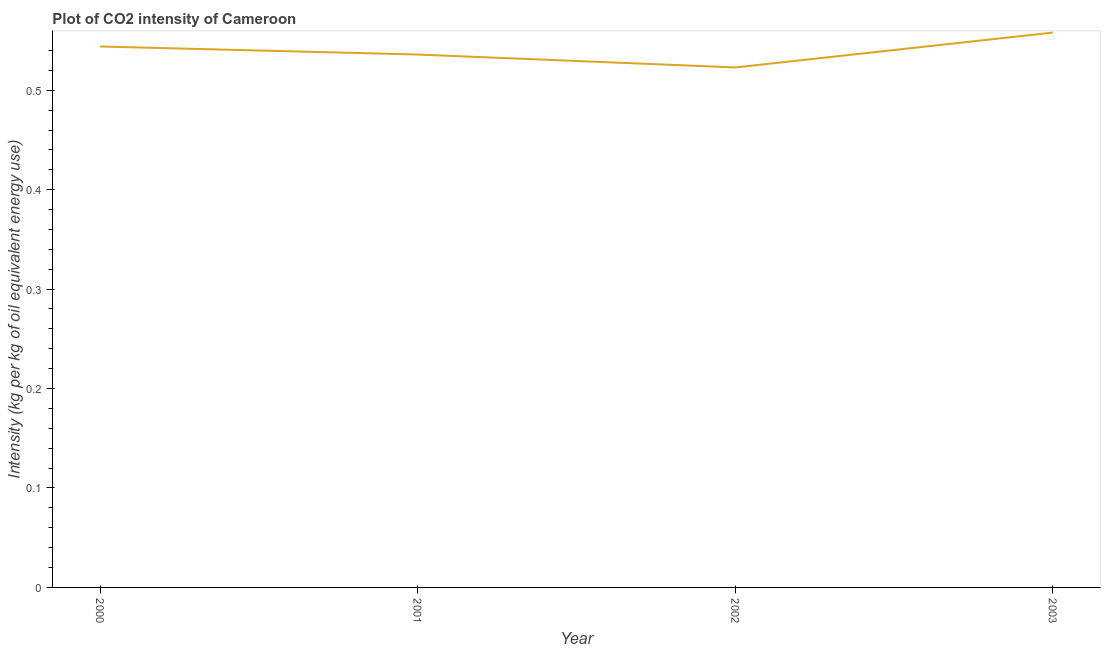What is the co2 intensity in 2002?
Keep it short and to the point. 0.52. Across all years, what is the maximum co2 intensity?
Provide a succinct answer. 0.56. Across all years, what is the minimum co2 intensity?
Your answer should be very brief. 0.52. What is the sum of the co2 intensity?
Offer a very short reply. 2.16. What is the difference between the co2 intensity in 2000 and 2002?
Make the answer very short. 0.02. What is the average co2 intensity per year?
Provide a succinct answer. 0.54. What is the median co2 intensity?
Offer a very short reply. 0.54. In how many years, is the co2 intensity greater than 0.32000000000000006 kg?
Make the answer very short. 4. What is the ratio of the co2 intensity in 2001 to that in 2002?
Your answer should be very brief. 1.02. What is the difference between the highest and the second highest co2 intensity?
Ensure brevity in your answer.  0.01. Is the sum of the co2 intensity in 2001 and 2003 greater than the maximum co2 intensity across all years?
Offer a terse response. Yes. What is the difference between the highest and the lowest co2 intensity?
Your response must be concise. 0.04. In how many years, is the co2 intensity greater than the average co2 intensity taken over all years?
Keep it short and to the point. 2. What is the difference between two consecutive major ticks on the Y-axis?
Offer a very short reply. 0.1. Does the graph contain grids?
Keep it short and to the point. No. What is the title of the graph?
Provide a short and direct response. Plot of CO2 intensity of Cameroon. What is the label or title of the X-axis?
Keep it short and to the point. Year. What is the label or title of the Y-axis?
Offer a terse response. Intensity (kg per kg of oil equivalent energy use). What is the Intensity (kg per kg of oil equivalent energy use) of 2000?
Make the answer very short. 0.54. What is the Intensity (kg per kg of oil equivalent energy use) of 2001?
Offer a terse response. 0.54. What is the Intensity (kg per kg of oil equivalent energy use) of 2002?
Your response must be concise. 0.52. What is the Intensity (kg per kg of oil equivalent energy use) of 2003?
Make the answer very short. 0.56. What is the difference between the Intensity (kg per kg of oil equivalent energy use) in 2000 and 2001?
Keep it short and to the point. 0.01. What is the difference between the Intensity (kg per kg of oil equivalent energy use) in 2000 and 2002?
Offer a terse response. 0.02. What is the difference between the Intensity (kg per kg of oil equivalent energy use) in 2000 and 2003?
Keep it short and to the point. -0.01. What is the difference between the Intensity (kg per kg of oil equivalent energy use) in 2001 and 2002?
Offer a terse response. 0.01. What is the difference between the Intensity (kg per kg of oil equivalent energy use) in 2001 and 2003?
Provide a succinct answer. -0.02. What is the difference between the Intensity (kg per kg of oil equivalent energy use) in 2002 and 2003?
Offer a very short reply. -0.04. What is the ratio of the Intensity (kg per kg of oil equivalent energy use) in 2000 to that in 2001?
Provide a short and direct response. 1.01. What is the ratio of the Intensity (kg per kg of oil equivalent energy use) in 2000 to that in 2003?
Give a very brief answer. 0.97. What is the ratio of the Intensity (kg per kg of oil equivalent energy use) in 2001 to that in 2002?
Your answer should be compact. 1.02. What is the ratio of the Intensity (kg per kg of oil equivalent energy use) in 2002 to that in 2003?
Your response must be concise. 0.94. 